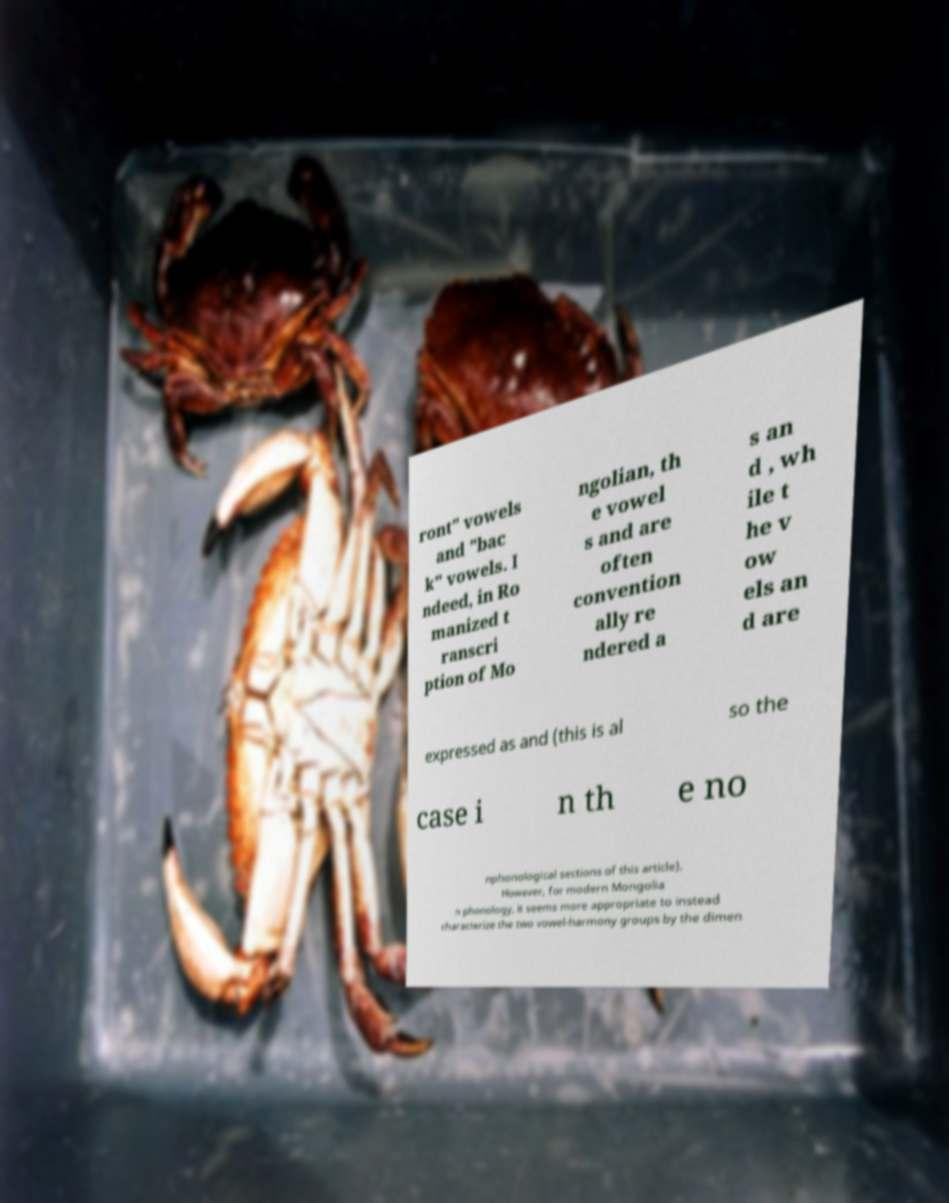Can you read and provide the text displayed in the image?This photo seems to have some interesting text. Can you extract and type it out for me? ront" vowels and "bac k" vowels. I ndeed, in Ro manized t ranscri ption of Mo ngolian, th e vowel s and are often convention ally re ndered a s an d , wh ile t he v ow els an d are expressed as and (this is al so the case i n th e no nphonological sections of this article). However, for modern Mongolia n phonology, it seems more appropriate to instead characterize the two vowel-harmony groups by the dimen 